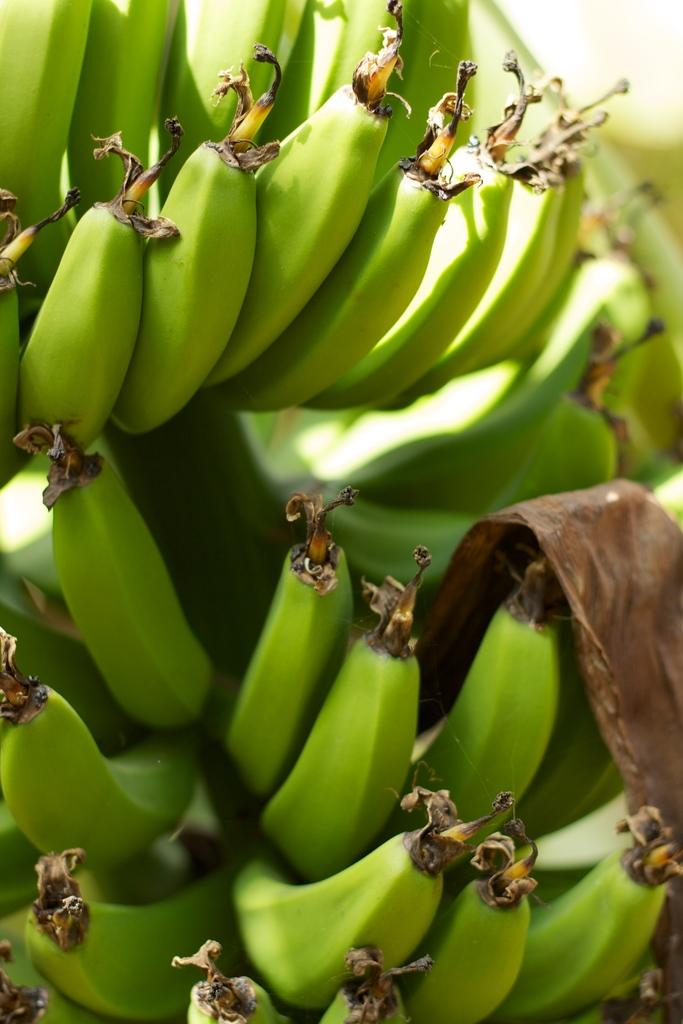What type of fruit is visible in the image? There are unripe bananas in the image. How many apple trees are present in the image? There are no apple trees or apples present in the image; it only features unripe bananas. What role does the brother play in the image? There is no mention of a brother or any people in the image; it only features unripe bananas. 